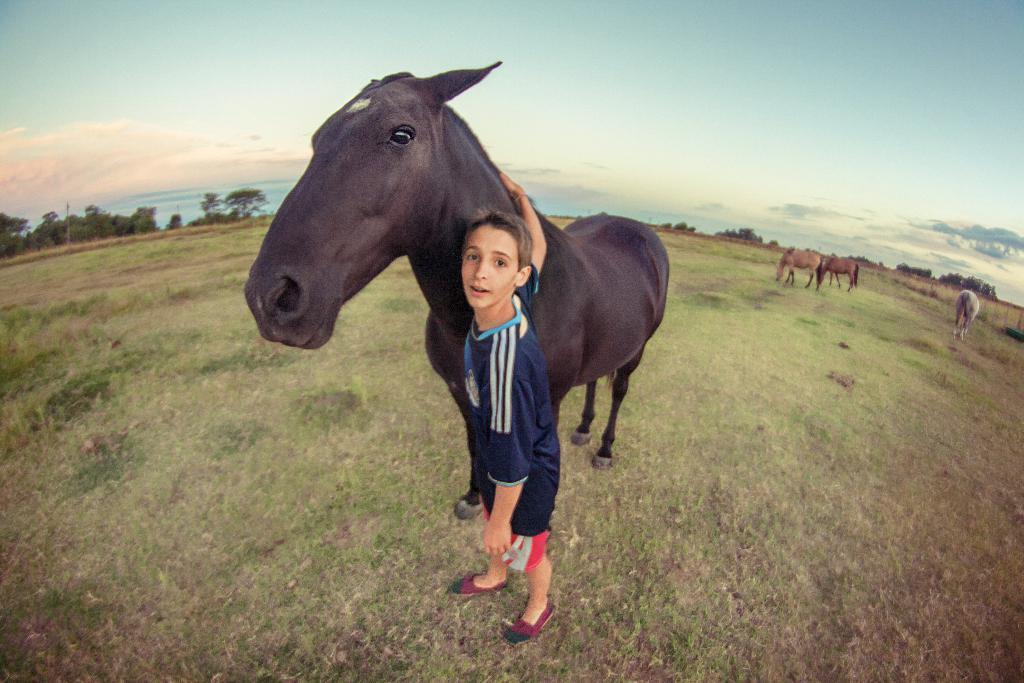Can you describe this image briefly? In this image, we can see a boy is standing and holding a horse. He is watching. On the right side, we can see few horses. At the bottom, we can see grass. Background there are few trees, plants and sky. On the left side of the image, we can see a pole. 